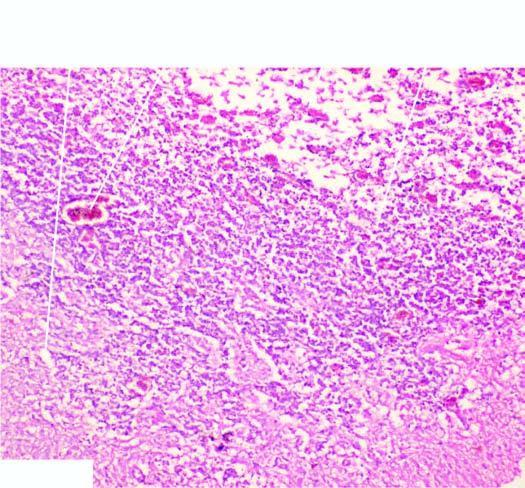what are the histologic change?
Answer the question using a single word or phrase. Reactive astrocytosis 